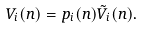Convert formula to latex. <formula><loc_0><loc_0><loc_500><loc_500>V _ { i } ( n ) = p _ { i } ( n ) \tilde { V } _ { i } ( n ) .</formula> 